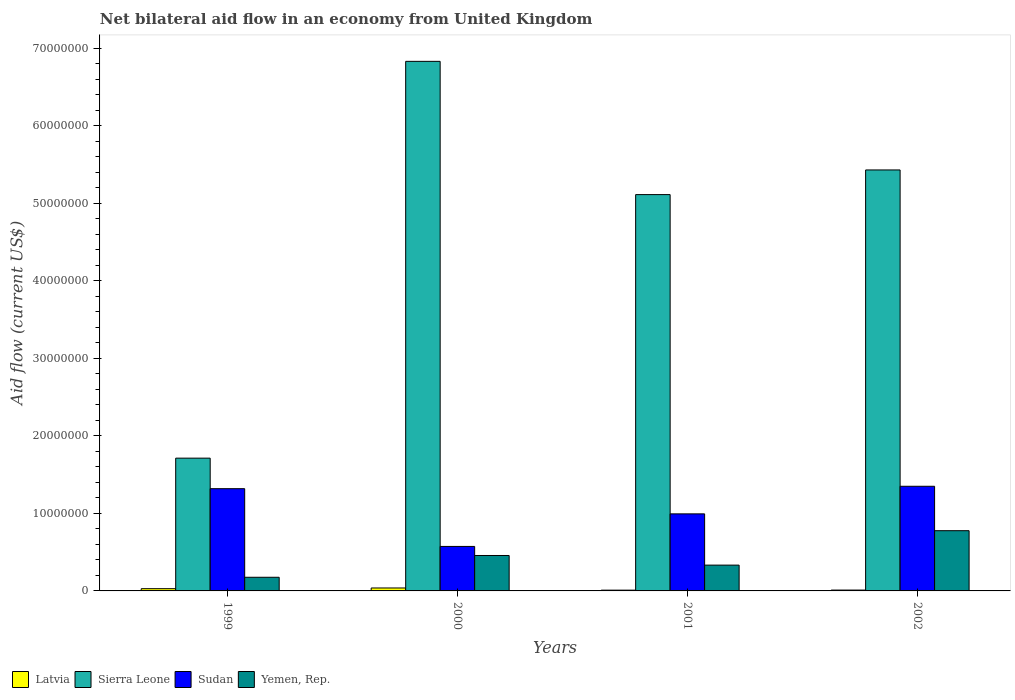How many bars are there on the 3rd tick from the right?
Your answer should be very brief. 4. What is the label of the 1st group of bars from the left?
Provide a short and direct response. 1999. In how many cases, is the number of bars for a given year not equal to the number of legend labels?
Your response must be concise. 0. What is the net bilateral aid flow in Sierra Leone in 2002?
Give a very brief answer. 5.43e+07. Across all years, what is the maximum net bilateral aid flow in Sudan?
Offer a very short reply. 1.35e+07. Across all years, what is the minimum net bilateral aid flow in Latvia?
Offer a very short reply. 1.00e+05. In which year was the net bilateral aid flow in Sudan minimum?
Keep it short and to the point. 2000. What is the total net bilateral aid flow in Sudan in the graph?
Ensure brevity in your answer.  4.24e+07. What is the difference between the net bilateral aid flow in Yemen, Rep. in 2001 and that in 2002?
Offer a very short reply. -4.44e+06. What is the difference between the net bilateral aid flow in Yemen, Rep. in 2000 and the net bilateral aid flow in Sierra Leone in 2002?
Offer a terse response. -4.97e+07. What is the average net bilateral aid flow in Yemen, Rep. per year?
Make the answer very short. 4.36e+06. In the year 2002, what is the difference between the net bilateral aid flow in Latvia and net bilateral aid flow in Yemen, Rep.?
Give a very brief answer. -7.66e+06. What is the ratio of the net bilateral aid flow in Sudan in 2001 to that in 2002?
Make the answer very short. 0.74. Is the net bilateral aid flow in Yemen, Rep. in 1999 less than that in 2001?
Your answer should be compact. Yes. Is the difference between the net bilateral aid flow in Latvia in 1999 and 2000 greater than the difference between the net bilateral aid flow in Yemen, Rep. in 1999 and 2000?
Make the answer very short. Yes. In how many years, is the net bilateral aid flow in Latvia greater than the average net bilateral aid flow in Latvia taken over all years?
Provide a succinct answer. 2. Is the sum of the net bilateral aid flow in Yemen, Rep. in 1999 and 2000 greater than the maximum net bilateral aid flow in Sierra Leone across all years?
Provide a short and direct response. No. Is it the case that in every year, the sum of the net bilateral aid flow in Sudan and net bilateral aid flow in Yemen, Rep. is greater than the sum of net bilateral aid flow in Sierra Leone and net bilateral aid flow in Latvia?
Provide a succinct answer. Yes. What does the 3rd bar from the left in 2002 represents?
Provide a succinct answer. Sudan. What does the 1st bar from the right in 2001 represents?
Ensure brevity in your answer.  Yemen, Rep. How many years are there in the graph?
Your answer should be very brief. 4. Are the values on the major ticks of Y-axis written in scientific E-notation?
Provide a short and direct response. No. Does the graph contain grids?
Offer a very short reply. No. Where does the legend appear in the graph?
Your response must be concise. Bottom left. How many legend labels are there?
Keep it short and to the point. 4. What is the title of the graph?
Your answer should be very brief. Net bilateral aid flow in an economy from United Kingdom. Does "Tunisia" appear as one of the legend labels in the graph?
Offer a terse response. No. What is the label or title of the X-axis?
Provide a short and direct response. Years. What is the Aid flow (current US$) in Sierra Leone in 1999?
Provide a short and direct response. 1.71e+07. What is the Aid flow (current US$) in Sudan in 1999?
Ensure brevity in your answer.  1.32e+07. What is the Aid flow (current US$) of Yemen, Rep. in 1999?
Offer a very short reply. 1.76e+06. What is the Aid flow (current US$) in Latvia in 2000?
Offer a very short reply. 3.80e+05. What is the Aid flow (current US$) of Sierra Leone in 2000?
Ensure brevity in your answer.  6.83e+07. What is the Aid flow (current US$) of Sudan in 2000?
Offer a terse response. 5.74e+06. What is the Aid flow (current US$) in Yemen, Rep. in 2000?
Make the answer very short. 4.57e+06. What is the Aid flow (current US$) of Latvia in 2001?
Make the answer very short. 1.00e+05. What is the Aid flow (current US$) in Sierra Leone in 2001?
Provide a succinct answer. 5.11e+07. What is the Aid flow (current US$) of Sudan in 2001?
Keep it short and to the point. 9.94e+06. What is the Aid flow (current US$) in Yemen, Rep. in 2001?
Your answer should be very brief. 3.33e+06. What is the Aid flow (current US$) of Sierra Leone in 2002?
Ensure brevity in your answer.  5.43e+07. What is the Aid flow (current US$) of Sudan in 2002?
Make the answer very short. 1.35e+07. What is the Aid flow (current US$) of Yemen, Rep. in 2002?
Offer a very short reply. 7.77e+06. Across all years, what is the maximum Aid flow (current US$) of Sierra Leone?
Your response must be concise. 6.83e+07. Across all years, what is the maximum Aid flow (current US$) of Sudan?
Provide a short and direct response. 1.35e+07. Across all years, what is the maximum Aid flow (current US$) in Yemen, Rep.?
Provide a succinct answer. 7.77e+06. Across all years, what is the minimum Aid flow (current US$) in Sierra Leone?
Keep it short and to the point. 1.71e+07. Across all years, what is the minimum Aid flow (current US$) in Sudan?
Your answer should be very brief. 5.74e+06. Across all years, what is the minimum Aid flow (current US$) of Yemen, Rep.?
Keep it short and to the point. 1.76e+06. What is the total Aid flow (current US$) in Latvia in the graph?
Your response must be concise. 8.80e+05. What is the total Aid flow (current US$) of Sierra Leone in the graph?
Offer a terse response. 1.91e+08. What is the total Aid flow (current US$) of Sudan in the graph?
Offer a terse response. 4.24e+07. What is the total Aid flow (current US$) in Yemen, Rep. in the graph?
Ensure brevity in your answer.  1.74e+07. What is the difference between the Aid flow (current US$) in Sierra Leone in 1999 and that in 2000?
Offer a terse response. -5.12e+07. What is the difference between the Aid flow (current US$) of Sudan in 1999 and that in 2000?
Provide a succinct answer. 7.45e+06. What is the difference between the Aid flow (current US$) in Yemen, Rep. in 1999 and that in 2000?
Your response must be concise. -2.81e+06. What is the difference between the Aid flow (current US$) of Latvia in 1999 and that in 2001?
Your response must be concise. 1.90e+05. What is the difference between the Aid flow (current US$) in Sierra Leone in 1999 and that in 2001?
Keep it short and to the point. -3.40e+07. What is the difference between the Aid flow (current US$) in Sudan in 1999 and that in 2001?
Provide a succinct answer. 3.25e+06. What is the difference between the Aid flow (current US$) in Yemen, Rep. in 1999 and that in 2001?
Provide a succinct answer. -1.57e+06. What is the difference between the Aid flow (current US$) of Sierra Leone in 1999 and that in 2002?
Provide a succinct answer. -3.72e+07. What is the difference between the Aid flow (current US$) of Sudan in 1999 and that in 2002?
Provide a succinct answer. -3.10e+05. What is the difference between the Aid flow (current US$) of Yemen, Rep. in 1999 and that in 2002?
Your response must be concise. -6.01e+06. What is the difference between the Aid flow (current US$) of Latvia in 2000 and that in 2001?
Provide a succinct answer. 2.80e+05. What is the difference between the Aid flow (current US$) of Sierra Leone in 2000 and that in 2001?
Make the answer very short. 1.72e+07. What is the difference between the Aid flow (current US$) in Sudan in 2000 and that in 2001?
Offer a very short reply. -4.20e+06. What is the difference between the Aid flow (current US$) in Yemen, Rep. in 2000 and that in 2001?
Provide a short and direct response. 1.24e+06. What is the difference between the Aid flow (current US$) in Latvia in 2000 and that in 2002?
Ensure brevity in your answer.  2.70e+05. What is the difference between the Aid flow (current US$) of Sierra Leone in 2000 and that in 2002?
Make the answer very short. 1.40e+07. What is the difference between the Aid flow (current US$) in Sudan in 2000 and that in 2002?
Give a very brief answer. -7.76e+06. What is the difference between the Aid flow (current US$) of Yemen, Rep. in 2000 and that in 2002?
Keep it short and to the point. -3.20e+06. What is the difference between the Aid flow (current US$) in Sierra Leone in 2001 and that in 2002?
Make the answer very short. -3.18e+06. What is the difference between the Aid flow (current US$) of Sudan in 2001 and that in 2002?
Ensure brevity in your answer.  -3.56e+06. What is the difference between the Aid flow (current US$) of Yemen, Rep. in 2001 and that in 2002?
Your answer should be compact. -4.44e+06. What is the difference between the Aid flow (current US$) in Latvia in 1999 and the Aid flow (current US$) in Sierra Leone in 2000?
Give a very brief answer. -6.80e+07. What is the difference between the Aid flow (current US$) in Latvia in 1999 and the Aid flow (current US$) in Sudan in 2000?
Offer a terse response. -5.45e+06. What is the difference between the Aid flow (current US$) in Latvia in 1999 and the Aid flow (current US$) in Yemen, Rep. in 2000?
Provide a short and direct response. -4.28e+06. What is the difference between the Aid flow (current US$) in Sierra Leone in 1999 and the Aid flow (current US$) in Sudan in 2000?
Offer a terse response. 1.14e+07. What is the difference between the Aid flow (current US$) in Sierra Leone in 1999 and the Aid flow (current US$) in Yemen, Rep. in 2000?
Provide a succinct answer. 1.26e+07. What is the difference between the Aid flow (current US$) in Sudan in 1999 and the Aid flow (current US$) in Yemen, Rep. in 2000?
Your response must be concise. 8.62e+06. What is the difference between the Aid flow (current US$) in Latvia in 1999 and the Aid flow (current US$) in Sierra Leone in 2001?
Offer a terse response. -5.08e+07. What is the difference between the Aid flow (current US$) of Latvia in 1999 and the Aid flow (current US$) of Sudan in 2001?
Provide a short and direct response. -9.65e+06. What is the difference between the Aid flow (current US$) of Latvia in 1999 and the Aid flow (current US$) of Yemen, Rep. in 2001?
Your response must be concise. -3.04e+06. What is the difference between the Aid flow (current US$) in Sierra Leone in 1999 and the Aid flow (current US$) in Sudan in 2001?
Provide a succinct answer. 7.19e+06. What is the difference between the Aid flow (current US$) of Sierra Leone in 1999 and the Aid flow (current US$) of Yemen, Rep. in 2001?
Your response must be concise. 1.38e+07. What is the difference between the Aid flow (current US$) in Sudan in 1999 and the Aid flow (current US$) in Yemen, Rep. in 2001?
Provide a short and direct response. 9.86e+06. What is the difference between the Aid flow (current US$) in Latvia in 1999 and the Aid flow (current US$) in Sierra Leone in 2002?
Offer a terse response. -5.40e+07. What is the difference between the Aid flow (current US$) of Latvia in 1999 and the Aid flow (current US$) of Sudan in 2002?
Ensure brevity in your answer.  -1.32e+07. What is the difference between the Aid flow (current US$) of Latvia in 1999 and the Aid flow (current US$) of Yemen, Rep. in 2002?
Give a very brief answer. -7.48e+06. What is the difference between the Aid flow (current US$) of Sierra Leone in 1999 and the Aid flow (current US$) of Sudan in 2002?
Your answer should be compact. 3.63e+06. What is the difference between the Aid flow (current US$) of Sierra Leone in 1999 and the Aid flow (current US$) of Yemen, Rep. in 2002?
Your answer should be very brief. 9.36e+06. What is the difference between the Aid flow (current US$) of Sudan in 1999 and the Aid flow (current US$) of Yemen, Rep. in 2002?
Offer a terse response. 5.42e+06. What is the difference between the Aid flow (current US$) of Latvia in 2000 and the Aid flow (current US$) of Sierra Leone in 2001?
Your answer should be compact. -5.08e+07. What is the difference between the Aid flow (current US$) in Latvia in 2000 and the Aid flow (current US$) in Sudan in 2001?
Offer a terse response. -9.56e+06. What is the difference between the Aid flow (current US$) of Latvia in 2000 and the Aid flow (current US$) of Yemen, Rep. in 2001?
Make the answer very short. -2.95e+06. What is the difference between the Aid flow (current US$) of Sierra Leone in 2000 and the Aid flow (current US$) of Sudan in 2001?
Provide a short and direct response. 5.84e+07. What is the difference between the Aid flow (current US$) in Sierra Leone in 2000 and the Aid flow (current US$) in Yemen, Rep. in 2001?
Provide a succinct answer. 6.50e+07. What is the difference between the Aid flow (current US$) of Sudan in 2000 and the Aid flow (current US$) of Yemen, Rep. in 2001?
Offer a very short reply. 2.41e+06. What is the difference between the Aid flow (current US$) of Latvia in 2000 and the Aid flow (current US$) of Sierra Leone in 2002?
Your response must be concise. -5.39e+07. What is the difference between the Aid flow (current US$) in Latvia in 2000 and the Aid flow (current US$) in Sudan in 2002?
Your answer should be very brief. -1.31e+07. What is the difference between the Aid flow (current US$) of Latvia in 2000 and the Aid flow (current US$) of Yemen, Rep. in 2002?
Give a very brief answer. -7.39e+06. What is the difference between the Aid flow (current US$) in Sierra Leone in 2000 and the Aid flow (current US$) in Sudan in 2002?
Ensure brevity in your answer.  5.48e+07. What is the difference between the Aid flow (current US$) in Sierra Leone in 2000 and the Aid flow (current US$) in Yemen, Rep. in 2002?
Your response must be concise. 6.06e+07. What is the difference between the Aid flow (current US$) of Sudan in 2000 and the Aid flow (current US$) of Yemen, Rep. in 2002?
Your response must be concise. -2.03e+06. What is the difference between the Aid flow (current US$) of Latvia in 2001 and the Aid flow (current US$) of Sierra Leone in 2002?
Your answer should be very brief. -5.42e+07. What is the difference between the Aid flow (current US$) of Latvia in 2001 and the Aid flow (current US$) of Sudan in 2002?
Your answer should be compact. -1.34e+07. What is the difference between the Aid flow (current US$) in Latvia in 2001 and the Aid flow (current US$) in Yemen, Rep. in 2002?
Your response must be concise. -7.67e+06. What is the difference between the Aid flow (current US$) of Sierra Leone in 2001 and the Aid flow (current US$) of Sudan in 2002?
Make the answer very short. 3.76e+07. What is the difference between the Aid flow (current US$) of Sierra Leone in 2001 and the Aid flow (current US$) of Yemen, Rep. in 2002?
Provide a short and direct response. 4.34e+07. What is the difference between the Aid flow (current US$) in Sudan in 2001 and the Aid flow (current US$) in Yemen, Rep. in 2002?
Offer a very short reply. 2.17e+06. What is the average Aid flow (current US$) in Sierra Leone per year?
Offer a terse response. 4.77e+07. What is the average Aid flow (current US$) in Sudan per year?
Offer a terse response. 1.06e+07. What is the average Aid flow (current US$) of Yemen, Rep. per year?
Your response must be concise. 4.36e+06. In the year 1999, what is the difference between the Aid flow (current US$) in Latvia and Aid flow (current US$) in Sierra Leone?
Ensure brevity in your answer.  -1.68e+07. In the year 1999, what is the difference between the Aid flow (current US$) in Latvia and Aid flow (current US$) in Sudan?
Offer a terse response. -1.29e+07. In the year 1999, what is the difference between the Aid flow (current US$) of Latvia and Aid flow (current US$) of Yemen, Rep.?
Provide a succinct answer. -1.47e+06. In the year 1999, what is the difference between the Aid flow (current US$) of Sierra Leone and Aid flow (current US$) of Sudan?
Give a very brief answer. 3.94e+06. In the year 1999, what is the difference between the Aid flow (current US$) in Sierra Leone and Aid flow (current US$) in Yemen, Rep.?
Provide a short and direct response. 1.54e+07. In the year 1999, what is the difference between the Aid flow (current US$) in Sudan and Aid flow (current US$) in Yemen, Rep.?
Offer a very short reply. 1.14e+07. In the year 2000, what is the difference between the Aid flow (current US$) of Latvia and Aid flow (current US$) of Sierra Leone?
Make the answer very short. -6.79e+07. In the year 2000, what is the difference between the Aid flow (current US$) of Latvia and Aid flow (current US$) of Sudan?
Your answer should be very brief. -5.36e+06. In the year 2000, what is the difference between the Aid flow (current US$) in Latvia and Aid flow (current US$) in Yemen, Rep.?
Your answer should be very brief. -4.19e+06. In the year 2000, what is the difference between the Aid flow (current US$) of Sierra Leone and Aid flow (current US$) of Sudan?
Offer a terse response. 6.26e+07. In the year 2000, what is the difference between the Aid flow (current US$) in Sierra Leone and Aid flow (current US$) in Yemen, Rep.?
Keep it short and to the point. 6.38e+07. In the year 2000, what is the difference between the Aid flow (current US$) of Sudan and Aid flow (current US$) of Yemen, Rep.?
Keep it short and to the point. 1.17e+06. In the year 2001, what is the difference between the Aid flow (current US$) in Latvia and Aid flow (current US$) in Sierra Leone?
Offer a very short reply. -5.10e+07. In the year 2001, what is the difference between the Aid flow (current US$) in Latvia and Aid flow (current US$) in Sudan?
Keep it short and to the point. -9.84e+06. In the year 2001, what is the difference between the Aid flow (current US$) of Latvia and Aid flow (current US$) of Yemen, Rep.?
Ensure brevity in your answer.  -3.23e+06. In the year 2001, what is the difference between the Aid flow (current US$) in Sierra Leone and Aid flow (current US$) in Sudan?
Offer a terse response. 4.12e+07. In the year 2001, what is the difference between the Aid flow (current US$) in Sierra Leone and Aid flow (current US$) in Yemen, Rep.?
Ensure brevity in your answer.  4.78e+07. In the year 2001, what is the difference between the Aid flow (current US$) of Sudan and Aid flow (current US$) of Yemen, Rep.?
Offer a very short reply. 6.61e+06. In the year 2002, what is the difference between the Aid flow (current US$) of Latvia and Aid flow (current US$) of Sierra Leone?
Your answer should be very brief. -5.42e+07. In the year 2002, what is the difference between the Aid flow (current US$) of Latvia and Aid flow (current US$) of Sudan?
Make the answer very short. -1.34e+07. In the year 2002, what is the difference between the Aid flow (current US$) of Latvia and Aid flow (current US$) of Yemen, Rep.?
Provide a short and direct response. -7.66e+06. In the year 2002, what is the difference between the Aid flow (current US$) in Sierra Leone and Aid flow (current US$) in Sudan?
Offer a very short reply. 4.08e+07. In the year 2002, what is the difference between the Aid flow (current US$) of Sierra Leone and Aid flow (current US$) of Yemen, Rep.?
Your response must be concise. 4.65e+07. In the year 2002, what is the difference between the Aid flow (current US$) in Sudan and Aid flow (current US$) in Yemen, Rep.?
Offer a very short reply. 5.73e+06. What is the ratio of the Aid flow (current US$) in Latvia in 1999 to that in 2000?
Make the answer very short. 0.76. What is the ratio of the Aid flow (current US$) of Sierra Leone in 1999 to that in 2000?
Offer a very short reply. 0.25. What is the ratio of the Aid flow (current US$) of Sudan in 1999 to that in 2000?
Ensure brevity in your answer.  2.3. What is the ratio of the Aid flow (current US$) of Yemen, Rep. in 1999 to that in 2000?
Provide a short and direct response. 0.39. What is the ratio of the Aid flow (current US$) in Latvia in 1999 to that in 2001?
Your answer should be very brief. 2.9. What is the ratio of the Aid flow (current US$) in Sierra Leone in 1999 to that in 2001?
Your response must be concise. 0.34. What is the ratio of the Aid flow (current US$) in Sudan in 1999 to that in 2001?
Ensure brevity in your answer.  1.33. What is the ratio of the Aid flow (current US$) in Yemen, Rep. in 1999 to that in 2001?
Offer a terse response. 0.53. What is the ratio of the Aid flow (current US$) in Latvia in 1999 to that in 2002?
Ensure brevity in your answer.  2.64. What is the ratio of the Aid flow (current US$) of Sierra Leone in 1999 to that in 2002?
Ensure brevity in your answer.  0.32. What is the ratio of the Aid flow (current US$) of Sudan in 1999 to that in 2002?
Provide a short and direct response. 0.98. What is the ratio of the Aid flow (current US$) in Yemen, Rep. in 1999 to that in 2002?
Make the answer very short. 0.23. What is the ratio of the Aid flow (current US$) of Latvia in 2000 to that in 2001?
Provide a short and direct response. 3.8. What is the ratio of the Aid flow (current US$) in Sierra Leone in 2000 to that in 2001?
Keep it short and to the point. 1.34. What is the ratio of the Aid flow (current US$) of Sudan in 2000 to that in 2001?
Make the answer very short. 0.58. What is the ratio of the Aid flow (current US$) of Yemen, Rep. in 2000 to that in 2001?
Keep it short and to the point. 1.37. What is the ratio of the Aid flow (current US$) of Latvia in 2000 to that in 2002?
Make the answer very short. 3.45. What is the ratio of the Aid flow (current US$) in Sierra Leone in 2000 to that in 2002?
Your response must be concise. 1.26. What is the ratio of the Aid flow (current US$) of Sudan in 2000 to that in 2002?
Make the answer very short. 0.43. What is the ratio of the Aid flow (current US$) in Yemen, Rep. in 2000 to that in 2002?
Provide a short and direct response. 0.59. What is the ratio of the Aid flow (current US$) of Latvia in 2001 to that in 2002?
Offer a terse response. 0.91. What is the ratio of the Aid flow (current US$) of Sierra Leone in 2001 to that in 2002?
Keep it short and to the point. 0.94. What is the ratio of the Aid flow (current US$) of Sudan in 2001 to that in 2002?
Ensure brevity in your answer.  0.74. What is the ratio of the Aid flow (current US$) in Yemen, Rep. in 2001 to that in 2002?
Make the answer very short. 0.43. What is the difference between the highest and the second highest Aid flow (current US$) in Latvia?
Your answer should be very brief. 9.00e+04. What is the difference between the highest and the second highest Aid flow (current US$) of Sierra Leone?
Give a very brief answer. 1.40e+07. What is the difference between the highest and the second highest Aid flow (current US$) of Sudan?
Keep it short and to the point. 3.10e+05. What is the difference between the highest and the second highest Aid flow (current US$) of Yemen, Rep.?
Your answer should be compact. 3.20e+06. What is the difference between the highest and the lowest Aid flow (current US$) in Latvia?
Keep it short and to the point. 2.80e+05. What is the difference between the highest and the lowest Aid flow (current US$) of Sierra Leone?
Keep it short and to the point. 5.12e+07. What is the difference between the highest and the lowest Aid flow (current US$) in Sudan?
Give a very brief answer. 7.76e+06. What is the difference between the highest and the lowest Aid flow (current US$) in Yemen, Rep.?
Provide a succinct answer. 6.01e+06. 